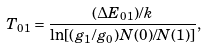<formula> <loc_0><loc_0><loc_500><loc_500>T _ { 0 1 } = \frac { ( \Delta E _ { 0 1 } ) / k } { \ln [ ( g _ { 1 } / g _ { 0 } ) N ( 0 ) / N ( 1 ) ] } ,</formula> 